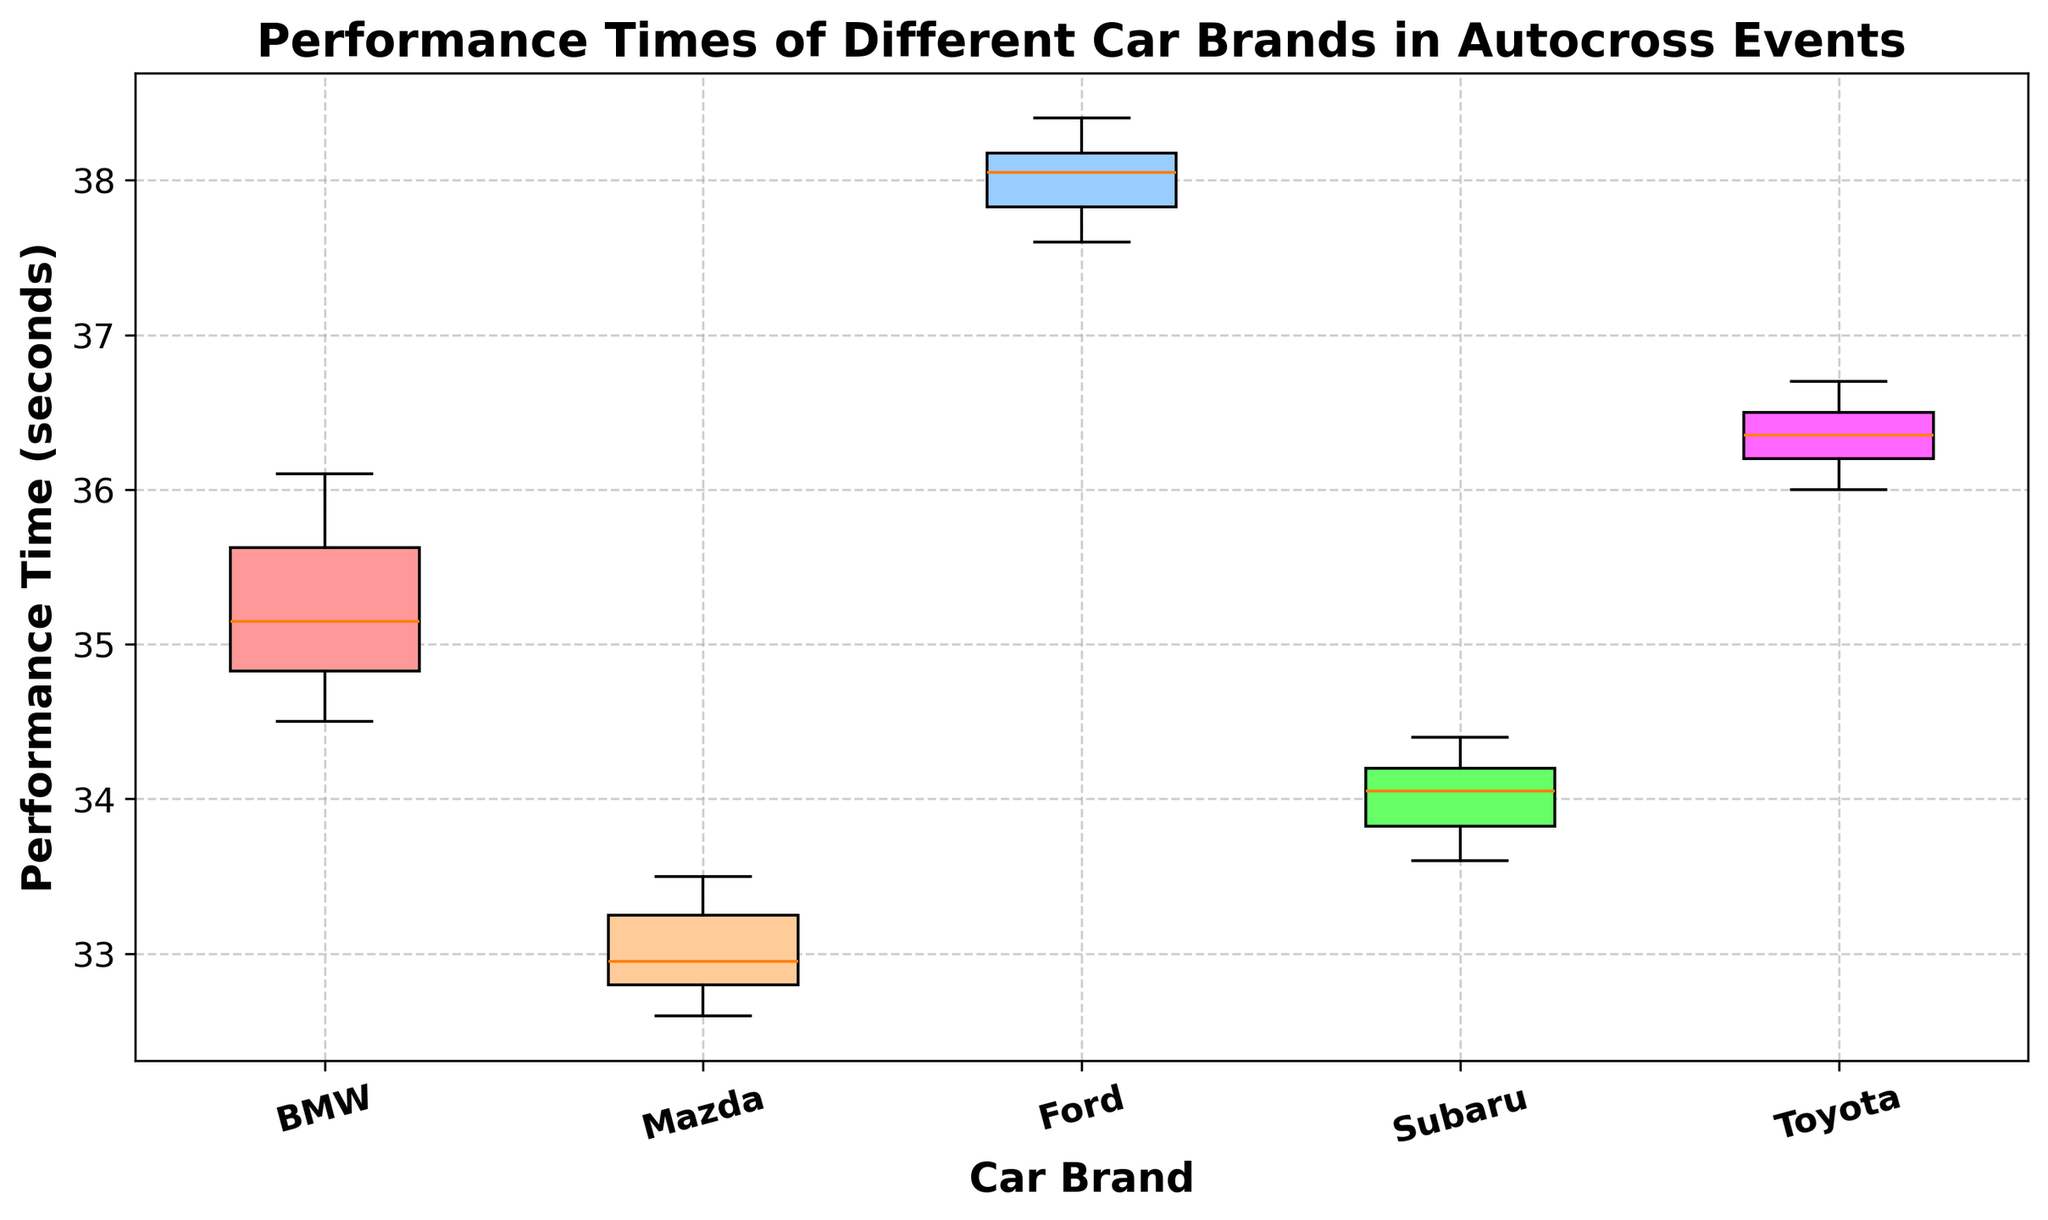Which car brand has the lowest median performance time? The median value can be determined by looking at the central line within each box plot. The box plot with the lowest median is the one where the central line is closest to the bottom of the figure.
Answer: Mazda Which car brand has the highest upper whisker in the box plot? The upper whisker is the vertical line that extends from the top of each box plot to the highest data value within 1.5 times the interquartile range from the box. By comparing the lengths of these whiskers, the longest one indicates the highest value.
Answer: Ford Which car brand has the most consistent performance times? Consistency can be judged by the spread of the box plot. The brand with the smallest interquartile range (IQR, the length of the box) shows the least variability. Identify the smallest box to find the most consistent brand.
Answer: Mazda What is the difference between the median performance times of BMW and Subaru? First, identify the median values of both BMW and Subaru from the central line of their respective box plots. Then, subtract the median value of Subaru from that of BMW.
Answer: 1.2 seconds Which two car brands have the most overlapping interquartile ranges (IQR)? Overlapping IQRs can be identified by examining the boxes and seeing which ones intersect the most horizontally. Look at the boxes to see which pair has the largest overlap.
Answer: BMW and Subaru What is the range of the performance times for Mazda? The range is defined as the difference between the maximum and minimum values, represented by the ends of the whiskers. Identify these values on the Mazda box plot and subtract the minimum from the maximum.
Answer: 0.9 seconds Does any car brand have outliers, and if so, which one(s)? Outliers are data points that fall outside the whiskers. Look for any dots or asterisks beyond the whiskers to identify if a brand has outliers.
Answer: None Which car brand has the shortest interquartile range (IQR)? The IQR is the length of the box in the box plot. The shortest box corresponds to the brand with the least IQR.
Answer: Mazda How much higher is the upper quartile of Toyota compared to Subaru? Identify the upper quartile (top edge of the box) of both Toyota and Subaru. Subtract the value of Subaru's upper quartile from that of Toyota's.
Answer: 2.4 seconds What is the visual feature that indicates variability in performance times among car brands? The visual feature indicating variability is the interquartile range (IQR), which is the length of the box in each box plot. Longer boxes denote higher variability, while shorter ones indicate lower variability.
Answer: IQR (Box Length) 